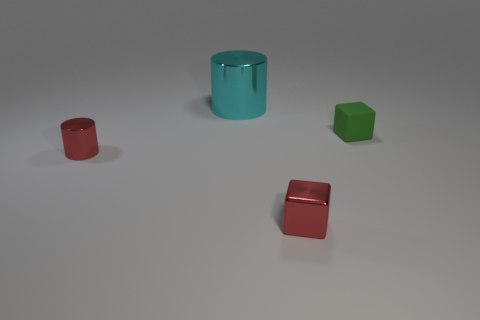Are there any tiny green cubes in front of the red cylinder?
Give a very brief answer. No. Is the number of metal objects in front of the green object less than the number of tiny purple cylinders?
Your response must be concise. No. What is the material of the tiny green cube?
Provide a short and direct response. Rubber. The big metallic cylinder is what color?
Make the answer very short. Cyan. What is the color of the object that is both behind the tiny red metal cylinder and on the left side of the shiny block?
Your response must be concise. Cyan. Are there any other things that are made of the same material as the cyan cylinder?
Your answer should be very brief. Yes. Does the cyan thing have the same material as the red object that is on the right side of the cyan object?
Offer a very short reply. Yes. There is a thing in front of the cylinder that is in front of the small green block; what size is it?
Provide a short and direct response. Small. Are there any other things that have the same color as the rubber thing?
Give a very brief answer. No. Do the red thing that is in front of the tiny cylinder and the cyan cylinder on the left side of the green rubber thing have the same material?
Offer a terse response. Yes. 